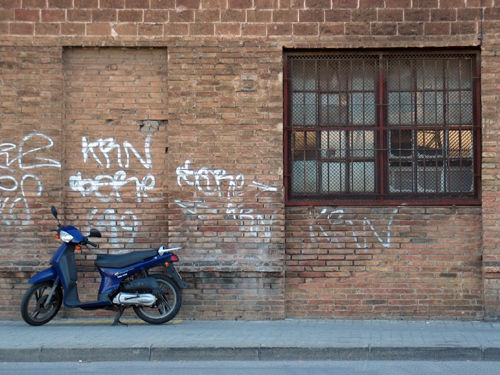Describe the objects in this image and their specific colors. I can see a motorcycle in gray, black, navy, and blue tones in this image. 